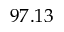<formula> <loc_0><loc_0><loc_500><loc_500>9 7 . 1 3</formula> 